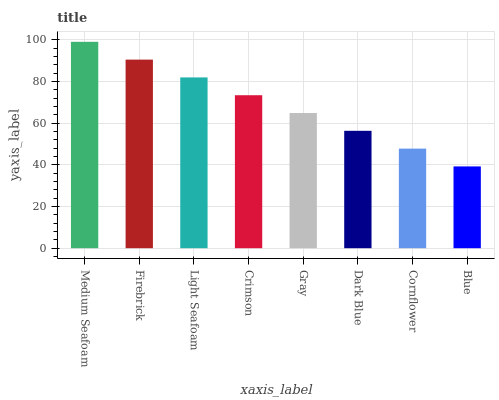Is Blue the minimum?
Answer yes or no. Yes. Is Medium Seafoam the maximum?
Answer yes or no. Yes. Is Firebrick the minimum?
Answer yes or no. No. Is Firebrick the maximum?
Answer yes or no. No. Is Medium Seafoam greater than Firebrick?
Answer yes or no. Yes. Is Firebrick less than Medium Seafoam?
Answer yes or no. Yes. Is Firebrick greater than Medium Seafoam?
Answer yes or no. No. Is Medium Seafoam less than Firebrick?
Answer yes or no. No. Is Crimson the high median?
Answer yes or no. Yes. Is Gray the low median?
Answer yes or no. Yes. Is Gray the high median?
Answer yes or no. No. Is Firebrick the low median?
Answer yes or no. No. 